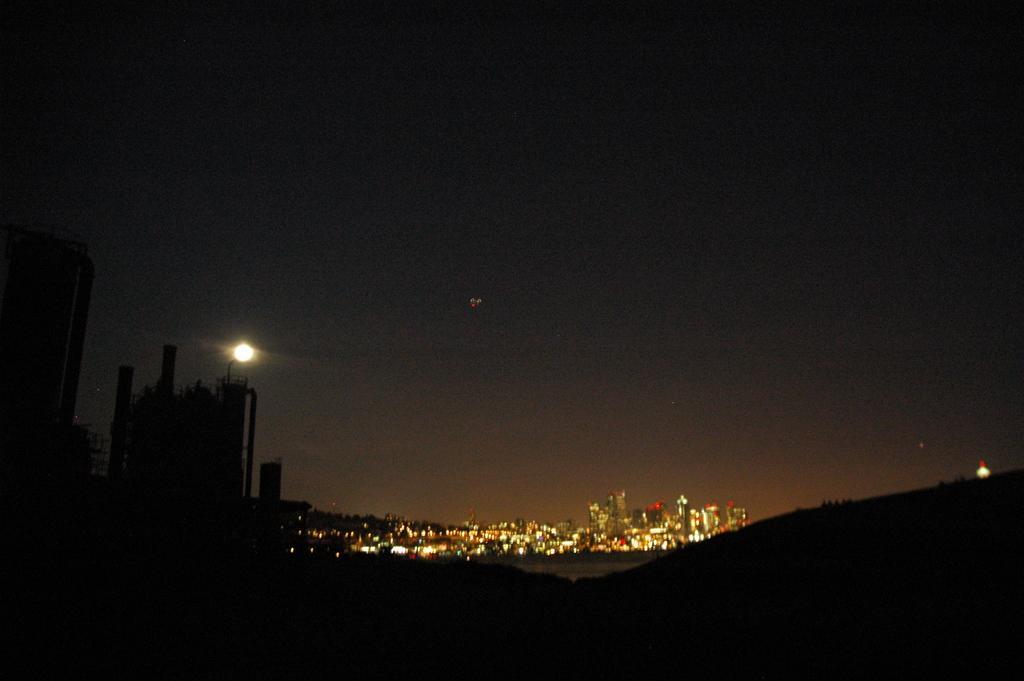Describe this image in one or two sentences. In this image we can see the moon, buildings with lights and the sky. 